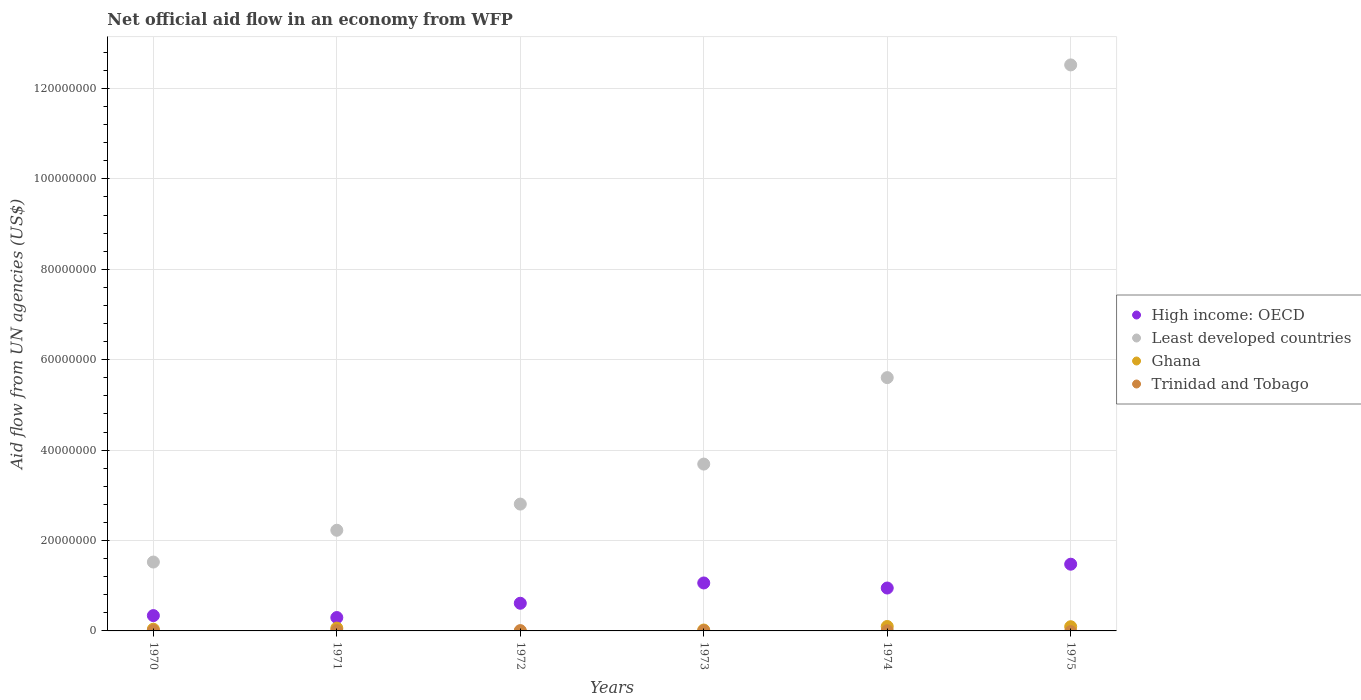How many different coloured dotlines are there?
Provide a short and direct response. 4. What is the net official aid flow in Least developed countries in 1973?
Your answer should be compact. 3.69e+07. Across all years, what is the maximum net official aid flow in Trinidad and Tobago?
Your answer should be compact. 7.00e+04. Across all years, what is the minimum net official aid flow in Least developed countries?
Your response must be concise. 1.52e+07. In which year was the net official aid flow in Trinidad and Tobago maximum?
Offer a very short reply. 1970. What is the difference between the net official aid flow in High income: OECD in 1970 and that in 1974?
Keep it short and to the point. -6.10e+06. What is the difference between the net official aid flow in Least developed countries in 1971 and the net official aid flow in Ghana in 1975?
Your answer should be very brief. 2.13e+07. What is the average net official aid flow in Trinidad and Tobago per year?
Your answer should be very brief. 4.67e+04. In the year 1971, what is the difference between the net official aid flow in Least developed countries and net official aid flow in Ghana?
Offer a very short reply. 2.16e+07. What is the ratio of the net official aid flow in Trinidad and Tobago in 1971 to that in 1972?
Provide a short and direct response. 1. Is the net official aid flow in Trinidad and Tobago in 1972 less than that in 1974?
Provide a short and direct response. No. Is the difference between the net official aid flow in Least developed countries in 1970 and 1973 greater than the difference between the net official aid flow in Ghana in 1970 and 1973?
Offer a very short reply. No. What is the difference between the highest and the second highest net official aid flow in Ghana?
Give a very brief answer. 5.00e+04. What is the difference between the highest and the lowest net official aid flow in High income: OECD?
Provide a short and direct response. 1.18e+07. Is it the case that in every year, the sum of the net official aid flow in Trinidad and Tobago and net official aid flow in Least developed countries  is greater than the net official aid flow in High income: OECD?
Give a very brief answer. Yes. Does the graph contain any zero values?
Your answer should be very brief. Yes. How many legend labels are there?
Make the answer very short. 4. What is the title of the graph?
Your response must be concise. Net official aid flow in an economy from WFP. What is the label or title of the X-axis?
Provide a short and direct response. Years. What is the label or title of the Y-axis?
Your answer should be compact. Aid flow from UN agencies (US$). What is the Aid flow from UN agencies (US$) of High income: OECD in 1970?
Provide a succinct answer. 3.39e+06. What is the Aid flow from UN agencies (US$) in Least developed countries in 1970?
Ensure brevity in your answer.  1.52e+07. What is the Aid flow from UN agencies (US$) in Ghana in 1970?
Make the answer very short. 3.80e+05. What is the Aid flow from UN agencies (US$) of Trinidad and Tobago in 1970?
Provide a succinct answer. 7.00e+04. What is the Aid flow from UN agencies (US$) of High income: OECD in 1971?
Your answer should be compact. 2.96e+06. What is the Aid flow from UN agencies (US$) of Least developed countries in 1971?
Offer a very short reply. 2.23e+07. What is the Aid flow from UN agencies (US$) of Ghana in 1971?
Ensure brevity in your answer.  6.20e+05. What is the Aid flow from UN agencies (US$) in Trinidad and Tobago in 1971?
Your answer should be compact. 7.00e+04. What is the Aid flow from UN agencies (US$) in High income: OECD in 1972?
Offer a terse response. 6.12e+06. What is the Aid flow from UN agencies (US$) of Least developed countries in 1972?
Give a very brief answer. 2.81e+07. What is the Aid flow from UN agencies (US$) in Ghana in 1972?
Keep it short and to the point. 0. What is the Aid flow from UN agencies (US$) of Trinidad and Tobago in 1972?
Your response must be concise. 7.00e+04. What is the Aid flow from UN agencies (US$) of High income: OECD in 1973?
Your answer should be compact. 1.06e+07. What is the Aid flow from UN agencies (US$) in Least developed countries in 1973?
Ensure brevity in your answer.  3.69e+07. What is the Aid flow from UN agencies (US$) of Ghana in 1973?
Ensure brevity in your answer.  2.00e+05. What is the Aid flow from UN agencies (US$) of Trinidad and Tobago in 1973?
Make the answer very short. 3.00e+04. What is the Aid flow from UN agencies (US$) of High income: OECD in 1974?
Your answer should be very brief. 9.49e+06. What is the Aid flow from UN agencies (US$) in Least developed countries in 1974?
Offer a terse response. 5.60e+07. What is the Aid flow from UN agencies (US$) of Ghana in 1974?
Provide a short and direct response. 9.80e+05. What is the Aid flow from UN agencies (US$) in Trinidad and Tobago in 1974?
Keep it short and to the point. 4.00e+04. What is the Aid flow from UN agencies (US$) in High income: OECD in 1975?
Give a very brief answer. 1.48e+07. What is the Aid flow from UN agencies (US$) in Least developed countries in 1975?
Give a very brief answer. 1.25e+08. What is the Aid flow from UN agencies (US$) in Ghana in 1975?
Your response must be concise. 9.30e+05. What is the Aid flow from UN agencies (US$) of Trinidad and Tobago in 1975?
Give a very brief answer. 0. Across all years, what is the maximum Aid flow from UN agencies (US$) of High income: OECD?
Your response must be concise. 1.48e+07. Across all years, what is the maximum Aid flow from UN agencies (US$) in Least developed countries?
Your response must be concise. 1.25e+08. Across all years, what is the maximum Aid flow from UN agencies (US$) in Ghana?
Keep it short and to the point. 9.80e+05. Across all years, what is the maximum Aid flow from UN agencies (US$) of Trinidad and Tobago?
Your response must be concise. 7.00e+04. Across all years, what is the minimum Aid flow from UN agencies (US$) in High income: OECD?
Your answer should be very brief. 2.96e+06. Across all years, what is the minimum Aid flow from UN agencies (US$) in Least developed countries?
Your answer should be very brief. 1.52e+07. Across all years, what is the minimum Aid flow from UN agencies (US$) of Ghana?
Your answer should be very brief. 0. What is the total Aid flow from UN agencies (US$) of High income: OECD in the graph?
Offer a terse response. 4.73e+07. What is the total Aid flow from UN agencies (US$) in Least developed countries in the graph?
Your answer should be compact. 2.84e+08. What is the total Aid flow from UN agencies (US$) of Ghana in the graph?
Your answer should be very brief. 3.11e+06. What is the total Aid flow from UN agencies (US$) in Trinidad and Tobago in the graph?
Ensure brevity in your answer.  2.80e+05. What is the difference between the Aid flow from UN agencies (US$) in High income: OECD in 1970 and that in 1971?
Ensure brevity in your answer.  4.30e+05. What is the difference between the Aid flow from UN agencies (US$) in Least developed countries in 1970 and that in 1971?
Give a very brief answer. -7.03e+06. What is the difference between the Aid flow from UN agencies (US$) of High income: OECD in 1970 and that in 1972?
Keep it short and to the point. -2.73e+06. What is the difference between the Aid flow from UN agencies (US$) of Least developed countries in 1970 and that in 1972?
Keep it short and to the point. -1.28e+07. What is the difference between the Aid flow from UN agencies (US$) of Trinidad and Tobago in 1970 and that in 1972?
Make the answer very short. 0. What is the difference between the Aid flow from UN agencies (US$) in High income: OECD in 1970 and that in 1973?
Provide a short and direct response. -7.22e+06. What is the difference between the Aid flow from UN agencies (US$) in Least developed countries in 1970 and that in 1973?
Your response must be concise. -2.17e+07. What is the difference between the Aid flow from UN agencies (US$) of Trinidad and Tobago in 1970 and that in 1973?
Keep it short and to the point. 4.00e+04. What is the difference between the Aid flow from UN agencies (US$) in High income: OECD in 1970 and that in 1974?
Your response must be concise. -6.10e+06. What is the difference between the Aid flow from UN agencies (US$) of Least developed countries in 1970 and that in 1974?
Your answer should be very brief. -4.08e+07. What is the difference between the Aid flow from UN agencies (US$) in Ghana in 1970 and that in 1974?
Make the answer very short. -6.00e+05. What is the difference between the Aid flow from UN agencies (US$) of Trinidad and Tobago in 1970 and that in 1974?
Give a very brief answer. 3.00e+04. What is the difference between the Aid flow from UN agencies (US$) of High income: OECD in 1970 and that in 1975?
Your answer should be compact. -1.14e+07. What is the difference between the Aid flow from UN agencies (US$) in Least developed countries in 1970 and that in 1975?
Your answer should be compact. -1.10e+08. What is the difference between the Aid flow from UN agencies (US$) in Ghana in 1970 and that in 1975?
Offer a terse response. -5.50e+05. What is the difference between the Aid flow from UN agencies (US$) of High income: OECD in 1971 and that in 1972?
Make the answer very short. -3.16e+06. What is the difference between the Aid flow from UN agencies (US$) of Least developed countries in 1971 and that in 1972?
Give a very brief answer. -5.79e+06. What is the difference between the Aid flow from UN agencies (US$) of Trinidad and Tobago in 1971 and that in 1972?
Offer a very short reply. 0. What is the difference between the Aid flow from UN agencies (US$) of High income: OECD in 1971 and that in 1973?
Provide a short and direct response. -7.65e+06. What is the difference between the Aid flow from UN agencies (US$) of Least developed countries in 1971 and that in 1973?
Your response must be concise. -1.46e+07. What is the difference between the Aid flow from UN agencies (US$) in Trinidad and Tobago in 1971 and that in 1973?
Make the answer very short. 4.00e+04. What is the difference between the Aid flow from UN agencies (US$) in High income: OECD in 1971 and that in 1974?
Provide a short and direct response. -6.53e+06. What is the difference between the Aid flow from UN agencies (US$) in Least developed countries in 1971 and that in 1974?
Make the answer very short. -3.38e+07. What is the difference between the Aid flow from UN agencies (US$) of Ghana in 1971 and that in 1974?
Ensure brevity in your answer.  -3.60e+05. What is the difference between the Aid flow from UN agencies (US$) of High income: OECD in 1971 and that in 1975?
Offer a terse response. -1.18e+07. What is the difference between the Aid flow from UN agencies (US$) of Least developed countries in 1971 and that in 1975?
Keep it short and to the point. -1.03e+08. What is the difference between the Aid flow from UN agencies (US$) of Ghana in 1971 and that in 1975?
Give a very brief answer. -3.10e+05. What is the difference between the Aid flow from UN agencies (US$) of High income: OECD in 1972 and that in 1973?
Provide a short and direct response. -4.49e+06. What is the difference between the Aid flow from UN agencies (US$) of Least developed countries in 1972 and that in 1973?
Make the answer very short. -8.85e+06. What is the difference between the Aid flow from UN agencies (US$) of High income: OECD in 1972 and that in 1974?
Give a very brief answer. -3.37e+06. What is the difference between the Aid flow from UN agencies (US$) of Least developed countries in 1972 and that in 1974?
Your response must be concise. -2.80e+07. What is the difference between the Aid flow from UN agencies (US$) of Trinidad and Tobago in 1972 and that in 1974?
Your response must be concise. 3.00e+04. What is the difference between the Aid flow from UN agencies (US$) in High income: OECD in 1972 and that in 1975?
Offer a very short reply. -8.64e+06. What is the difference between the Aid flow from UN agencies (US$) in Least developed countries in 1972 and that in 1975?
Keep it short and to the point. -9.72e+07. What is the difference between the Aid flow from UN agencies (US$) in High income: OECD in 1973 and that in 1974?
Your answer should be very brief. 1.12e+06. What is the difference between the Aid flow from UN agencies (US$) in Least developed countries in 1973 and that in 1974?
Ensure brevity in your answer.  -1.91e+07. What is the difference between the Aid flow from UN agencies (US$) in Ghana in 1973 and that in 1974?
Make the answer very short. -7.80e+05. What is the difference between the Aid flow from UN agencies (US$) of High income: OECD in 1973 and that in 1975?
Your answer should be compact. -4.15e+06. What is the difference between the Aid flow from UN agencies (US$) of Least developed countries in 1973 and that in 1975?
Ensure brevity in your answer.  -8.83e+07. What is the difference between the Aid flow from UN agencies (US$) in Ghana in 1973 and that in 1975?
Give a very brief answer. -7.30e+05. What is the difference between the Aid flow from UN agencies (US$) in High income: OECD in 1974 and that in 1975?
Your answer should be compact. -5.27e+06. What is the difference between the Aid flow from UN agencies (US$) in Least developed countries in 1974 and that in 1975?
Your answer should be compact. -6.92e+07. What is the difference between the Aid flow from UN agencies (US$) of High income: OECD in 1970 and the Aid flow from UN agencies (US$) of Least developed countries in 1971?
Your answer should be very brief. -1.89e+07. What is the difference between the Aid flow from UN agencies (US$) of High income: OECD in 1970 and the Aid flow from UN agencies (US$) of Ghana in 1971?
Offer a terse response. 2.77e+06. What is the difference between the Aid flow from UN agencies (US$) of High income: OECD in 1970 and the Aid flow from UN agencies (US$) of Trinidad and Tobago in 1971?
Provide a succinct answer. 3.32e+06. What is the difference between the Aid flow from UN agencies (US$) in Least developed countries in 1970 and the Aid flow from UN agencies (US$) in Ghana in 1971?
Provide a short and direct response. 1.46e+07. What is the difference between the Aid flow from UN agencies (US$) of Least developed countries in 1970 and the Aid flow from UN agencies (US$) of Trinidad and Tobago in 1971?
Your answer should be very brief. 1.52e+07. What is the difference between the Aid flow from UN agencies (US$) of Ghana in 1970 and the Aid flow from UN agencies (US$) of Trinidad and Tobago in 1971?
Your answer should be very brief. 3.10e+05. What is the difference between the Aid flow from UN agencies (US$) in High income: OECD in 1970 and the Aid flow from UN agencies (US$) in Least developed countries in 1972?
Your answer should be very brief. -2.47e+07. What is the difference between the Aid flow from UN agencies (US$) in High income: OECD in 1970 and the Aid flow from UN agencies (US$) in Trinidad and Tobago in 1972?
Your answer should be very brief. 3.32e+06. What is the difference between the Aid flow from UN agencies (US$) of Least developed countries in 1970 and the Aid flow from UN agencies (US$) of Trinidad and Tobago in 1972?
Give a very brief answer. 1.52e+07. What is the difference between the Aid flow from UN agencies (US$) in Ghana in 1970 and the Aid flow from UN agencies (US$) in Trinidad and Tobago in 1972?
Ensure brevity in your answer.  3.10e+05. What is the difference between the Aid flow from UN agencies (US$) in High income: OECD in 1970 and the Aid flow from UN agencies (US$) in Least developed countries in 1973?
Provide a short and direct response. -3.35e+07. What is the difference between the Aid flow from UN agencies (US$) in High income: OECD in 1970 and the Aid flow from UN agencies (US$) in Ghana in 1973?
Provide a short and direct response. 3.19e+06. What is the difference between the Aid flow from UN agencies (US$) in High income: OECD in 1970 and the Aid flow from UN agencies (US$) in Trinidad and Tobago in 1973?
Provide a succinct answer. 3.36e+06. What is the difference between the Aid flow from UN agencies (US$) of Least developed countries in 1970 and the Aid flow from UN agencies (US$) of Ghana in 1973?
Give a very brief answer. 1.50e+07. What is the difference between the Aid flow from UN agencies (US$) in Least developed countries in 1970 and the Aid flow from UN agencies (US$) in Trinidad and Tobago in 1973?
Keep it short and to the point. 1.52e+07. What is the difference between the Aid flow from UN agencies (US$) in Ghana in 1970 and the Aid flow from UN agencies (US$) in Trinidad and Tobago in 1973?
Your answer should be compact. 3.50e+05. What is the difference between the Aid flow from UN agencies (US$) of High income: OECD in 1970 and the Aid flow from UN agencies (US$) of Least developed countries in 1974?
Give a very brief answer. -5.26e+07. What is the difference between the Aid flow from UN agencies (US$) of High income: OECD in 1970 and the Aid flow from UN agencies (US$) of Ghana in 1974?
Offer a very short reply. 2.41e+06. What is the difference between the Aid flow from UN agencies (US$) of High income: OECD in 1970 and the Aid flow from UN agencies (US$) of Trinidad and Tobago in 1974?
Provide a short and direct response. 3.35e+06. What is the difference between the Aid flow from UN agencies (US$) of Least developed countries in 1970 and the Aid flow from UN agencies (US$) of Ghana in 1974?
Your answer should be very brief. 1.43e+07. What is the difference between the Aid flow from UN agencies (US$) of Least developed countries in 1970 and the Aid flow from UN agencies (US$) of Trinidad and Tobago in 1974?
Your response must be concise. 1.52e+07. What is the difference between the Aid flow from UN agencies (US$) in High income: OECD in 1970 and the Aid flow from UN agencies (US$) in Least developed countries in 1975?
Make the answer very short. -1.22e+08. What is the difference between the Aid flow from UN agencies (US$) in High income: OECD in 1970 and the Aid flow from UN agencies (US$) in Ghana in 1975?
Provide a succinct answer. 2.46e+06. What is the difference between the Aid flow from UN agencies (US$) in Least developed countries in 1970 and the Aid flow from UN agencies (US$) in Ghana in 1975?
Ensure brevity in your answer.  1.43e+07. What is the difference between the Aid flow from UN agencies (US$) in High income: OECD in 1971 and the Aid flow from UN agencies (US$) in Least developed countries in 1972?
Keep it short and to the point. -2.51e+07. What is the difference between the Aid flow from UN agencies (US$) of High income: OECD in 1971 and the Aid flow from UN agencies (US$) of Trinidad and Tobago in 1972?
Give a very brief answer. 2.89e+06. What is the difference between the Aid flow from UN agencies (US$) in Least developed countries in 1971 and the Aid flow from UN agencies (US$) in Trinidad and Tobago in 1972?
Your answer should be very brief. 2.22e+07. What is the difference between the Aid flow from UN agencies (US$) of Ghana in 1971 and the Aid flow from UN agencies (US$) of Trinidad and Tobago in 1972?
Offer a very short reply. 5.50e+05. What is the difference between the Aid flow from UN agencies (US$) in High income: OECD in 1971 and the Aid flow from UN agencies (US$) in Least developed countries in 1973?
Keep it short and to the point. -3.40e+07. What is the difference between the Aid flow from UN agencies (US$) in High income: OECD in 1971 and the Aid flow from UN agencies (US$) in Ghana in 1973?
Ensure brevity in your answer.  2.76e+06. What is the difference between the Aid flow from UN agencies (US$) of High income: OECD in 1971 and the Aid flow from UN agencies (US$) of Trinidad and Tobago in 1973?
Your answer should be very brief. 2.93e+06. What is the difference between the Aid flow from UN agencies (US$) in Least developed countries in 1971 and the Aid flow from UN agencies (US$) in Ghana in 1973?
Keep it short and to the point. 2.21e+07. What is the difference between the Aid flow from UN agencies (US$) in Least developed countries in 1971 and the Aid flow from UN agencies (US$) in Trinidad and Tobago in 1973?
Give a very brief answer. 2.22e+07. What is the difference between the Aid flow from UN agencies (US$) in Ghana in 1971 and the Aid flow from UN agencies (US$) in Trinidad and Tobago in 1973?
Your answer should be very brief. 5.90e+05. What is the difference between the Aid flow from UN agencies (US$) in High income: OECD in 1971 and the Aid flow from UN agencies (US$) in Least developed countries in 1974?
Your response must be concise. -5.31e+07. What is the difference between the Aid flow from UN agencies (US$) in High income: OECD in 1971 and the Aid flow from UN agencies (US$) in Ghana in 1974?
Your answer should be very brief. 1.98e+06. What is the difference between the Aid flow from UN agencies (US$) in High income: OECD in 1971 and the Aid flow from UN agencies (US$) in Trinidad and Tobago in 1974?
Ensure brevity in your answer.  2.92e+06. What is the difference between the Aid flow from UN agencies (US$) in Least developed countries in 1971 and the Aid flow from UN agencies (US$) in Ghana in 1974?
Make the answer very short. 2.13e+07. What is the difference between the Aid flow from UN agencies (US$) of Least developed countries in 1971 and the Aid flow from UN agencies (US$) of Trinidad and Tobago in 1974?
Keep it short and to the point. 2.22e+07. What is the difference between the Aid flow from UN agencies (US$) in Ghana in 1971 and the Aid flow from UN agencies (US$) in Trinidad and Tobago in 1974?
Provide a short and direct response. 5.80e+05. What is the difference between the Aid flow from UN agencies (US$) of High income: OECD in 1971 and the Aid flow from UN agencies (US$) of Least developed countries in 1975?
Your response must be concise. -1.22e+08. What is the difference between the Aid flow from UN agencies (US$) in High income: OECD in 1971 and the Aid flow from UN agencies (US$) in Ghana in 1975?
Provide a succinct answer. 2.03e+06. What is the difference between the Aid flow from UN agencies (US$) in Least developed countries in 1971 and the Aid flow from UN agencies (US$) in Ghana in 1975?
Provide a short and direct response. 2.13e+07. What is the difference between the Aid flow from UN agencies (US$) in High income: OECD in 1972 and the Aid flow from UN agencies (US$) in Least developed countries in 1973?
Offer a terse response. -3.08e+07. What is the difference between the Aid flow from UN agencies (US$) of High income: OECD in 1972 and the Aid flow from UN agencies (US$) of Ghana in 1973?
Your response must be concise. 5.92e+06. What is the difference between the Aid flow from UN agencies (US$) of High income: OECD in 1972 and the Aid flow from UN agencies (US$) of Trinidad and Tobago in 1973?
Keep it short and to the point. 6.09e+06. What is the difference between the Aid flow from UN agencies (US$) in Least developed countries in 1972 and the Aid flow from UN agencies (US$) in Ghana in 1973?
Give a very brief answer. 2.79e+07. What is the difference between the Aid flow from UN agencies (US$) of Least developed countries in 1972 and the Aid flow from UN agencies (US$) of Trinidad and Tobago in 1973?
Your answer should be compact. 2.80e+07. What is the difference between the Aid flow from UN agencies (US$) in High income: OECD in 1972 and the Aid flow from UN agencies (US$) in Least developed countries in 1974?
Keep it short and to the point. -4.99e+07. What is the difference between the Aid flow from UN agencies (US$) in High income: OECD in 1972 and the Aid flow from UN agencies (US$) in Ghana in 1974?
Your answer should be very brief. 5.14e+06. What is the difference between the Aid flow from UN agencies (US$) of High income: OECD in 1972 and the Aid flow from UN agencies (US$) of Trinidad and Tobago in 1974?
Make the answer very short. 6.08e+06. What is the difference between the Aid flow from UN agencies (US$) of Least developed countries in 1972 and the Aid flow from UN agencies (US$) of Ghana in 1974?
Ensure brevity in your answer.  2.71e+07. What is the difference between the Aid flow from UN agencies (US$) in Least developed countries in 1972 and the Aid flow from UN agencies (US$) in Trinidad and Tobago in 1974?
Your answer should be compact. 2.80e+07. What is the difference between the Aid flow from UN agencies (US$) of High income: OECD in 1972 and the Aid flow from UN agencies (US$) of Least developed countries in 1975?
Keep it short and to the point. -1.19e+08. What is the difference between the Aid flow from UN agencies (US$) in High income: OECD in 1972 and the Aid flow from UN agencies (US$) in Ghana in 1975?
Provide a succinct answer. 5.19e+06. What is the difference between the Aid flow from UN agencies (US$) of Least developed countries in 1972 and the Aid flow from UN agencies (US$) of Ghana in 1975?
Ensure brevity in your answer.  2.71e+07. What is the difference between the Aid flow from UN agencies (US$) of High income: OECD in 1973 and the Aid flow from UN agencies (US$) of Least developed countries in 1974?
Offer a terse response. -4.54e+07. What is the difference between the Aid flow from UN agencies (US$) of High income: OECD in 1973 and the Aid flow from UN agencies (US$) of Ghana in 1974?
Offer a very short reply. 9.63e+06. What is the difference between the Aid flow from UN agencies (US$) of High income: OECD in 1973 and the Aid flow from UN agencies (US$) of Trinidad and Tobago in 1974?
Your response must be concise. 1.06e+07. What is the difference between the Aid flow from UN agencies (US$) of Least developed countries in 1973 and the Aid flow from UN agencies (US$) of Ghana in 1974?
Your response must be concise. 3.59e+07. What is the difference between the Aid flow from UN agencies (US$) of Least developed countries in 1973 and the Aid flow from UN agencies (US$) of Trinidad and Tobago in 1974?
Provide a short and direct response. 3.69e+07. What is the difference between the Aid flow from UN agencies (US$) in High income: OECD in 1973 and the Aid flow from UN agencies (US$) in Least developed countries in 1975?
Ensure brevity in your answer.  -1.15e+08. What is the difference between the Aid flow from UN agencies (US$) of High income: OECD in 1973 and the Aid flow from UN agencies (US$) of Ghana in 1975?
Provide a succinct answer. 9.68e+06. What is the difference between the Aid flow from UN agencies (US$) of Least developed countries in 1973 and the Aid flow from UN agencies (US$) of Ghana in 1975?
Offer a very short reply. 3.60e+07. What is the difference between the Aid flow from UN agencies (US$) in High income: OECD in 1974 and the Aid flow from UN agencies (US$) in Least developed countries in 1975?
Your answer should be very brief. -1.16e+08. What is the difference between the Aid flow from UN agencies (US$) of High income: OECD in 1974 and the Aid flow from UN agencies (US$) of Ghana in 1975?
Your answer should be very brief. 8.56e+06. What is the difference between the Aid flow from UN agencies (US$) in Least developed countries in 1974 and the Aid flow from UN agencies (US$) in Ghana in 1975?
Offer a terse response. 5.51e+07. What is the average Aid flow from UN agencies (US$) of High income: OECD per year?
Your answer should be very brief. 7.89e+06. What is the average Aid flow from UN agencies (US$) of Least developed countries per year?
Give a very brief answer. 4.73e+07. What is the average Aid flow from UN agencies (US$) of Ghana per year?
Provide a short and direct response. 5.18e+05. What is the average Aid flow from UN agencies (US$) in Trinidad and Tobago per year?
Keep it short and to the point. 4.67e+04. In the year 1970, what is the difference between the Aid flow from UN agencies (US$) in High income: OECD and Aid flow from UN agencies (US$) in Least developed countries?
Your answer should be very brief. -1.18e+07. In the year 1970, what is the difference between the Aid flow from UN agencies (US$) in High income: OECD and Aid flow from UN agencies (US$) in Ghana?
Make the answer very short. 3.01e+06. In the year 1970, what is the difference between the Aid flow from UN agencies (US$) in High income: OECD and Aid flow from UN agencies (US$) in Trinidad and Tobago?
Your answer should be compact. 3.32e+06. In the year 1970, what is the difference between the Aid flow from UN agencies (US$) of Least developed countries and Aid flow from UN agencies (US$) of Ghana?
Your answer should be compact. 1.49e+07. In the year 1970, what is the difference between the Aid flow from UN agencies (US$) in Least developed countries and Aid flow from UN agencies (US$) in Trinidad and Tobago?
Your answer should be compact. 1.52e+07. In the year 1971, what is the difference between the Aid flow from UN agencies (US$) of High income: OECD and Aid flow from UN agencies (US$) of Least developed countries?
Ensure brevity in your answer.  -1.93e+07. In the year 1971, what is the difference between the Aid flow from UN agencies (US$) of High income: OECD and Aid flow from UN agencies (US$) of Ghana?
Your answer should be compact. 2.34e+06. In the year 1971, what is the difference between the Aid flow from UN agencies (US$) of High income: OECD and Aid flow from UN agencies (US$) of Trinidad and Tobago?
Offer a very short reply. 2.89e+06. In the year 1971, what is the difference between the Aid flow from UN agencies (US$) of Least developed countries and Aid flow from UN agencies (US$) of Ghana?
Offer a very short reply. 2.16e+07. In the year 1971, what is the difference between the Aid flow from UN agencies (US$) in Least developed countries and Aid flow from UN agencies (US$) in Trinidad and Tobago?
Offer a terse response. 2.22e+07. In the year 1972, what is the difference between the Aid flow from UN agencies (US$) of High income: OECD and Aid flow from UN agencies (US$) of Least developed countries?
Ensure brevity in your answer.  -2.19e+07. In the year 1972, what is the difference between the Aid flow from UN agencies (US$) of High income: OECD and Aid flow from UN agencies (US$) of Trinidad and Tobago?
Your response must be concise. 6.05e+06. In the year 1972, what is the difference between the Aid flow from UN agencies (US$) of Least developed countries and Aid flow from UN agencies (US$) of Trinidad and Tobago?
Your response must be concise. 2.80e+07. In the year 1973, what is the difference between the Aid flow from UN agencies (US$) of High income: OECD and Aid flow from UN agencies (US$) of Least developed countries?
Make the answer very short. -2.63e+07. In the year 1973, what is the difference between the Aid flow from UN agencies (US$) in High income: OECD and Aid flow from UN agencies (US$) in Ghana?
Give a very brief answer. 1.04e+07. In the year 1973, what is the difference between the Aid flow from UN agencies (US$) of High income: OECD and Aid flow from UN agencies (US$) of Trinidad and Tobago?
Make the answer very short. 1.06e+07. In the year 1973, what is the difference between the Aid flow from UN agencies (US$) of Least developed countries and Aid flow from UN agencies (US$) of Ghana?
Keep it short and to the point. 3.67e+07. In the year 1973, what is the difference between the Aid flow from UN agencies (US$) of Least developed countries and Aid flow from UN agencies (US$) of Trinidad and Tobago?
Your answer should be compact. 3.69e+07. In the year 1973, what is the difference between the Aid flow from UN agencies (US$) of Ghana and Aid flow from UN agencies (US$) of Trinidad and Tobago?
Keep it short and to the point. 1.70e+05. In the year 1974, what is the difference between the Aid flow from UN agencies (US$) in High income: OECD and Aid flow from UN agencies (US$) in Least developed countries?
Ensure brevity in your answer.  -4.66e+07. In the year 1974, what is the difference between the Aid flow from UN agencies (US$) of High income: OECD and Aid flow from UN agencies (US$) of Ghana?
Provide a succinct answer. 8.51e+06. In the year 1974, what is the difference between the Aid flow from UN agencies (US$) in High income: OECD and Aid flow from UN agencies (US$) in Trinidad and Tobago?
Offer a very short reply. 9.45e+06. In the year 1974, what is the difference between the Aid flow from UN agencies (US$) of Least developed countries and Aid flow from UN agencies (US$) of Ghana?
Ensure brevity in your answer.  5.51e+07. In the year 1974, what is the difference between the Aid flow from UN agencies (US$) in Least developed countries and Aid flow from UN agencies (US$) in Trinidad and Tobago?
Your answer should be compact. 5.60e+07. In the year 1974, what is the difference between the Aid flow from UN agencies (US$) of Ghana and Aid flow from UN agencies (US$) of Trinidad and Tobago?
Your answer should be compact. 9.40e+05. In the year 1975, what is the difference between the Aid flow from UN agencies (US$) of High income: OECD and Aid flow from UN agencies (US$) of Least developed countries?
Offer a very short reply. -1.10e+08. In the year 1975, what is the difference between the Aid flow from UN agencies (US$) in High income: OECD and Aid flow from UN agencies (US$) in Ghana?
Offer a very short reply. 1.38e+07. In the year 1975, what is the difference between the Aid flow from UN agencies (US$) of Least developed countries and Aid flow from UN agencies (US$) of Ghana?
Make the answer very short. 1.24e+08. What is the ratio of the Aid flow from UN agencies (US$) in High income: OECD in 1970 to that in 1971?
Your answer should be compact. 1.15. What is the ratio of the Aid flow from UN agencies (US$) of Least developed countries in 1970 to that in 1971?
Your answer should be compact. 0.68. What is the ratio of the Aid flow from UN agencies (US$) in Ghana in 1970 to that in 1971?
Your response must be concise. 0.61. What is the ratio of the Aid flow from UN agencies (US$) in Trinidad and Tobago in 1970 to that in 1971?
Give a very brief answer. 1. What is the ratio of the Aid flow from UN agencies (US$) in High income: OECD in 1970 to that in 1972?
Offer a very short reply. 0.55. What is the ratio of the Aid flow from UN agencies (US$) in Least developed countries in 1970 to that in 1972?
Offer a very short reply. 0.54. What is the ratio of the Aid flow from UN agencies (US$) of High income: OECD in 1970 to that in 1973?
Make the answer very short. 0.32. What is the ratio of the Aid flow from UN agencies (US$) of Least developed countries in 1970 to that in 1973?
Provide a succinct answer. 0.41. What is the ratio of the Aid flow from UN agencies (US$) of Trinidad and Tobago in 1970 to that in 1973?
Offer a terse response. 2.33. What is the ratio of the Aid flow from UN agencies (US$) of High income: OECD in 1970 to that in 1974?
Give a very brief answer. 0.36. What is the ratio of the Aid flow from UN agencies (US$) of Least developed countries in 1970 to that in 1974?
Make the answer very short. 0.27. What is the ratio of the Aid flow from UN agencies (US$) in Ghana in 1970 to that in 1974?
Give a very brief answer. 0.39. What is the ratio of the Aid flow from UN agencies (US$) in Trinidad and Tobago in 1970 to that in 1974?
Give a very brief answer. 1.75. What is the ratio of the Aid flow from UN agencies (US$) in High income: OECD in 1970 to that in 1975?
Keep it short and to the point. 0.23. What is the ratio of the Aid flow from UN agencies (US$) of Least developed countries in 1970 to that in 1975?
Give a very brief answer. 0.12. What is the ratio of the Aid flow from UN agencies (US$) in Ghana in 1970 to that in 1975?
Provide a short and direct response. 0.41. What is the ratio of the Aid flow from UN agencies (US$) of High income: OECD in 1971 to that in 1972?
Your answer should be very brief. 0.48. What is the ratio of the Aid flow from UN agencies (US$) in Least developed countries in 1971 to that in 1972?
Ensure brevity in your answer.  0.79. What is the ratio of the Aid flow from UN agencies (US$) in High income: OECD in 1971 to that in 1973?
Offer a terse response. 0.28. What is the ratio of the Aid flow from UN agencies (US$) in Least developed countries in 1971 to that in 1973?
Your response must be concise. 0.6. What is the ratio of the Aid flow from UN agencies (US$) of Ghana in 1971 to that in 1973?
Your response must be concise. 3.1. What is the ratio of the Aid flow from UN agencies (US$) in Trinidad and Tobago in 1971 to that in 1973?
Ensure brevity in your answer.  2.33. What is the ratio of the Aid flow from UN agencies (US$) of High income: OECD in 1971 to that in 1974?
Make the answer very short. 0.31. What is the ratio of the Aid flow from UN agencies (US$) of Least developed countries in 1971 to that in 1974?
Your response must be concise. 0.4. What is the ratio of the Aid flow from UN agencies (US$) in Ghana in 1971 to that in 1974?
Provide a short and direct response. 0.63. What is the ratio of the Aid flow from UN agencies (US$) in High income: OECD in 1971 to that in 1975?
Offer a terse response. 0.2. What is the ratio of the Aid flow from UN agencies (US$) in Least developed countries in 1971 to that in 1975?
Give a very brief answer. 0.18. What is the ratio of the Aid flow from UN agencies (US$) of High income: OECD in 1972 to that in 1973?
Offer a terse response. 0.58. What is the ratio of the Aid flow from UN agencies (US$) in Least developed countries in 1972 to that in 1973?
Keep it short and to the point. 0.76. What is the ratio of the Aid flow from UN agencies (US$) in Trinidad and Tobago in 1972 to that in 1973?
Offer a terse response. 2.33. What is the ratio of the Aid flow from UN agencies (US$) in High income: OECD in 1972 to that in 1974?
Your response must be concise. 0.64. What is the ratio of the Aid flow from UN agencies (US$) of Least developed countries in 1972 to that in 1974?
Make the answer very short. 0.5. What is the ratio of the Aid flow from UN agencies (US$) of Trinidad and Tobago in 1972 to that in 1974?
Give a very brief answer. 1.75. What is the ratio of the Aid flow from UN agencies (US$) in High income: OECD in 1972 to that in 1975?
Ensure brevity in your answer.  0.41. What is the ratio of the Aid flow from UN agencies (US$) of Least developed countries in 1972 to that in 1975?
Make the answer very short. 0.22. What is the ratio of the Aid flow from UN agencies (US$) of High income: OECD in 1973 to that in 1974?
Offer a very short reply. 1.12. What is the ratio of the Aid flow from UN agencies (US$) in Least developed countries in 1973 to that in 1974?
Your answer should be very brief. 0.66. What is the ratio of the Aid flow from UN agencies (US$) in Ghana in 1973 to that in 1974?
Your answer should be very brief. 0.2. What is the ratio of the Aid flow from UN agencies (US$) of High income: OECD in 1973 to that in 1975?
Give a very brief answer. 0.72. What is the ratio of the Aid flow from UN agencies (US$) of Least developed countries in 1973 to that in 1975?
Your answer should be very brief. 0.29. What is the ratio of the Aid flow from UN agencies (US$) in Ghana in 1973 to that in 1975?
Your answer should be compact. 0.22. What is the ratio of the Aid flow from UN agencies (US$) in High income: OECD in 1974 to that in 1975?
Your response must be concise. 0.64. What is the ratio of the Aid flow from UN agencies (US$) of Least developed countries in 1974 to that in 1975?
Your answer should be very brief. 0.45. What is the ratio of the Aid flow from UN agencies (US$) of Ghana in 1974 to that in 1975?
Provide a short and direct response. 1.05. What is the difference between the highest and the second highest Aid flow from UN agencies (US$) of High income: OECD?
Provide a short and direct response. 4.15e+06. What is the difference between the highest and the second highest Aid flow from UN agencies (US$) of Least developed countries?
Keep it short and to the point. 6.92e+07. What is the difference between the highest and the second highest Aid flow from UN agencies (US$) of Ghana?
Your response must be concise. 5.00e+04. What is the difference between the highest and the lowest Aid flow from UN agencies (US$) of High income: OECD?
Your answer should be very brief. 1.18e+07. What is the difference between the highest and the lowest Aid flow from UN agencies (US$) of Least developed countries?
Offer a very short reply. 1.10e+08. What is the difference between the highest and the lowest Aid flow from UN agencies (US$) of Ghana?
Make the answer very short. 9.80e+05. What is the difference between the highest and the lowest Aid flow from UN agencies (US$) in Trinidad and Tobago?
Give a very brief answer. 7.00e+04. 